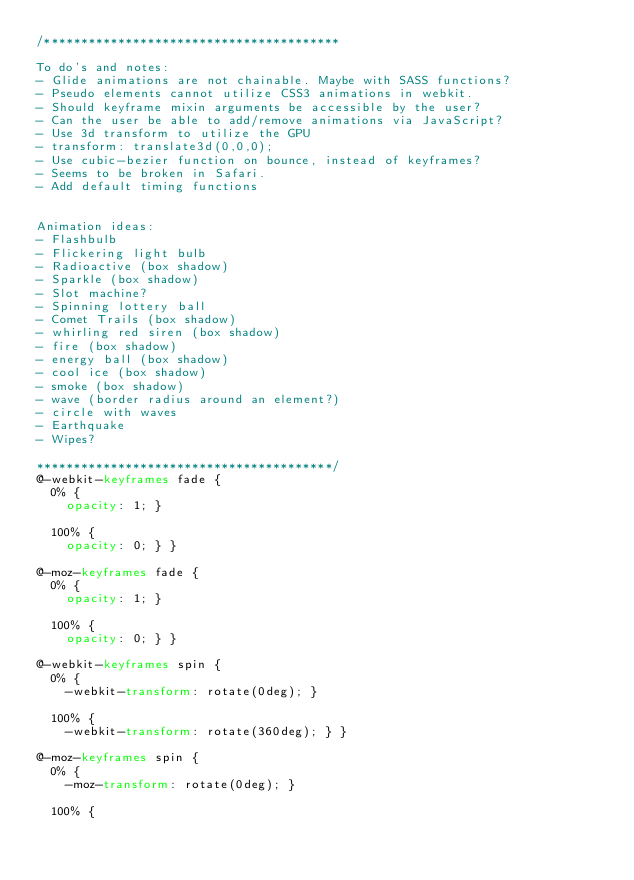<code> <loc_0><loc_0><loc_500><loc_500><_CSS_>/****************************************

To do's and notes:
- Glide animations are not chainable. Maybe with SASS functions?
- Pseudo elements cannot utilize CSS3 animations in webkit.
- Should keyframe mixin arguments be accessible by the user?
- Can the user be able to add/remove animations via JavaScript?
- Use 3d transform to utilize the GPU
- transform: translate3d(0,0,0);
- Use cubic-bezier function on bounce, instead of keyframes?
- Seems to be broken in Safari.
- Add default timing functions


Animation ideas:
- Flashbulb
- Flickering light bulb
- Radioactive (box shadow)
- Sparkle (box shadow)
- Slot machine?
- Spinning lottery ball
- Comet Trails (box shadow)
- whirling red siren (box shadow)
- fire (box shadow)
- energy ball (box shadow)
- cool ice (box shadow)
- smoke (box shadow)
- wave (border radius around an element?)
- circle with waves
- Earthquake
- Wipes?

****************************************/
@-webkit-keyframes fade {
  0% {
    opacity: 1; }

  100% {
    opacity: 0; } }

@-moz-keyframes fade {
  0% {
    opacity: 1; }

  100% {
    opacity: 0; } }

@-webkit-keyframes spin {
  0% {
    -webkit-transform: rotate(0deg); }

  100% {
    -webkit-transform: rotate(360deg); } }

@-moz-keyframes spin {
  0% {
    -moz-transform: rotate(0deg); }

  100% {</code> 